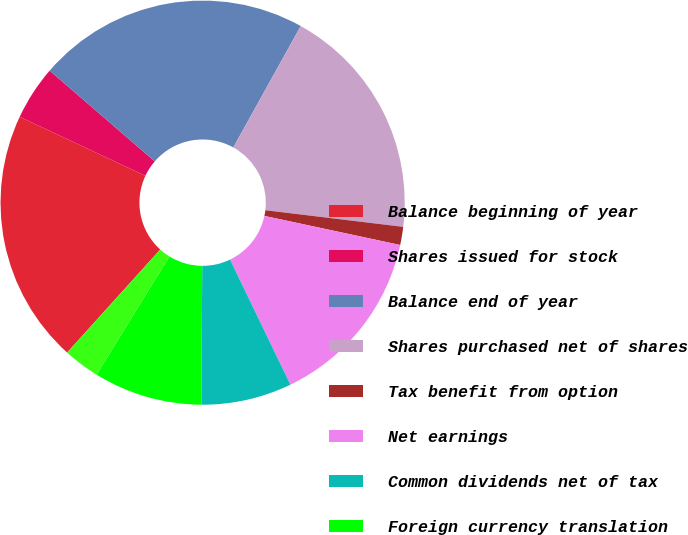<chart> <loc_0><loc_0><loc_500><loc_500><pie_chart><fcel>Balance beginning of year<fcel>Shares issued for stock<fcel>Balance end of year<fcel>Shares purchased net of shares<fcel>Tax benefit from option<fcel>Net earnings<fcel>Common dividends net of tax<fcel>Foreign currency translation<fcel>Change in minimum pension<nl><fcel>20.29%<fcel>4.35%<fcel>21.74%<fcel>18.84%<fcel>1.45%<fcel>14.49%<fcel>7.25%<fcel>8.7%<fcel>2.9%<nl></chart> 